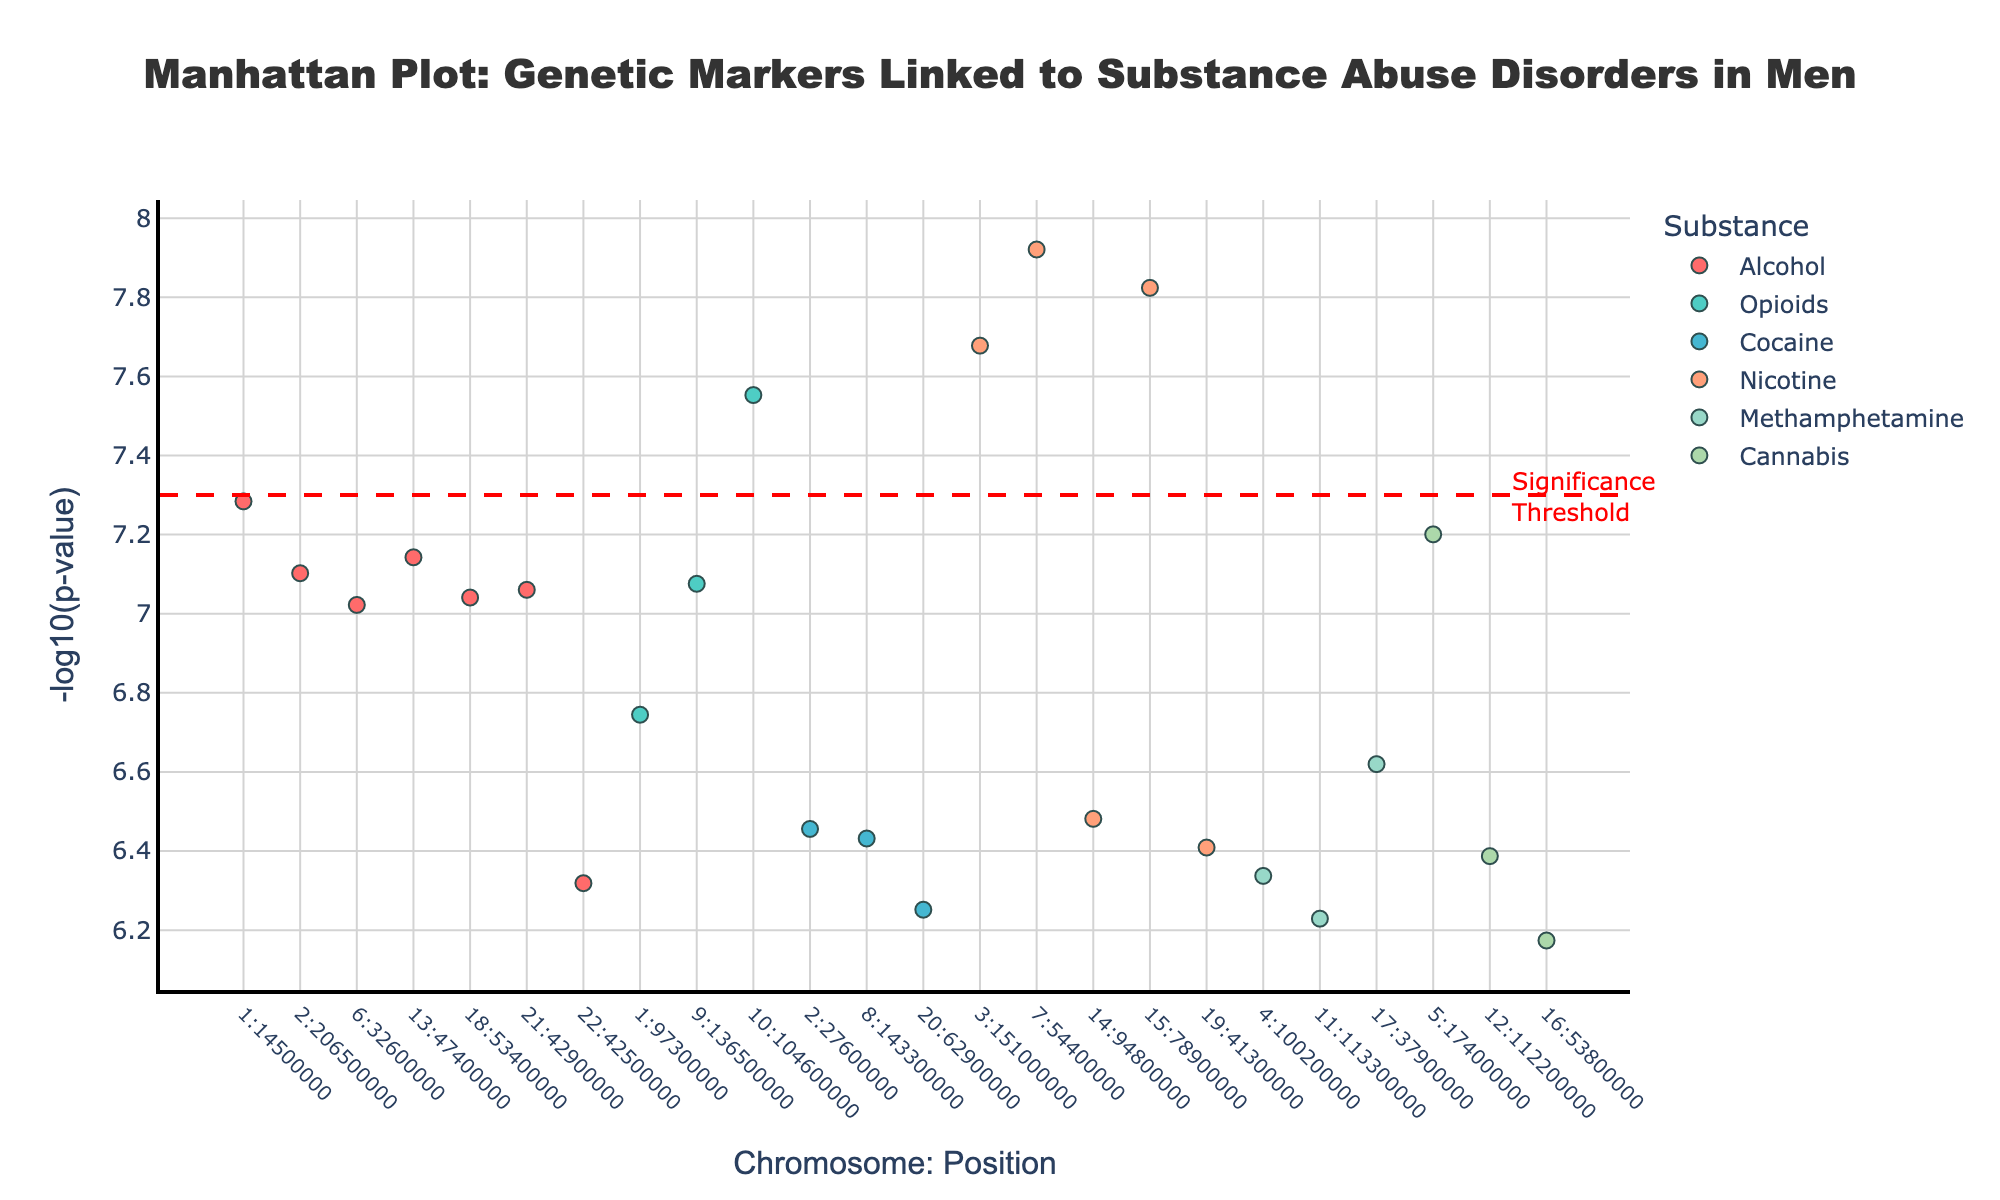What's the title of the plot? The title is located at the top of the plot, representing the main subject. It reads: "Manhattan Plot: Genetic Markers Linked to Substance Abuse Disorders in Men."
Answer: Manhattan Plot: Genetic Markers Linked to Substance Abuse Disorders in Men What is the x-axis label? The x-axis label is written below the horizontal axis and denotes the positional attribute in the format "Chromosome: Position".
Answer: Chromosome: Position How many data points are there for Alcohol? By examining the color map, Alcohol’s markers are in a specific red shade. Counting these red markers, we find seven data points for Alcohol.
Answer: 7 Which substance has the lowest p-value data point? The lowest p-value corresponds to the highest -log10(p) value. By identifying the tallest marker, which is for Nicotine with the SNP rs16969968 on chromosome 15, we determine it as the one for Nicotine.
Answer: Nicotine Are there any substances that have multiple significant SNPs on the same chromosome? If so, which one(s) and on which chromosome(s)? By examining the chromosome locations for each substance, we find multiple SNPs for Alcohol on chromosome 1 and for Nicotine on chromosome 15.
Answer: Alcohol (Chromosome 1), Nicotine (Chromosome 15) What substances have data points with -log10(p) values higher than the significance threshold? Observing markers above the horizontal threshold line at y = 7.3, the substances Alcohol, Opioids, and Nicotine have these high -log10(p) values.
Answer: Alcohol, Opioids, Nicotine Which SNP has the highest -log10(p) value, and what is its substance association? The highest -log10(p) value corresponds to the tallest marker. This marker is SNP rs16969968, which is associated with Nicotine.
Answer: rs16969968, Nicotine On which chromosome does the SNP rs2055650 associated with Alcohol reside? Looking for the SNP rs2055650 in the Alcohol markers, we see it positioned on chromosome 21.
Answer: Chromosome 21 How many distinct substances are represented in the plot? By identifying the unique substances in the legend, we count a total of six substances: Alcohol, Opioids, Cocaine, Nicotine, Methamphetamine, and Cannabis.
Answer: 6 Which substance has the most SNPs with significant p-values on different chromosomes? By counting the unique chromosomes for each substance, Nicotine has significant SNPs on multiple chromosomes: 3, 7, 9, 14, 15, 19.
Answer: Nicotine 